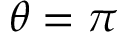Convert formula to latex. <formula><loc_0><loc_0><loc_500><loc_500>\theta = \pi</formula> 